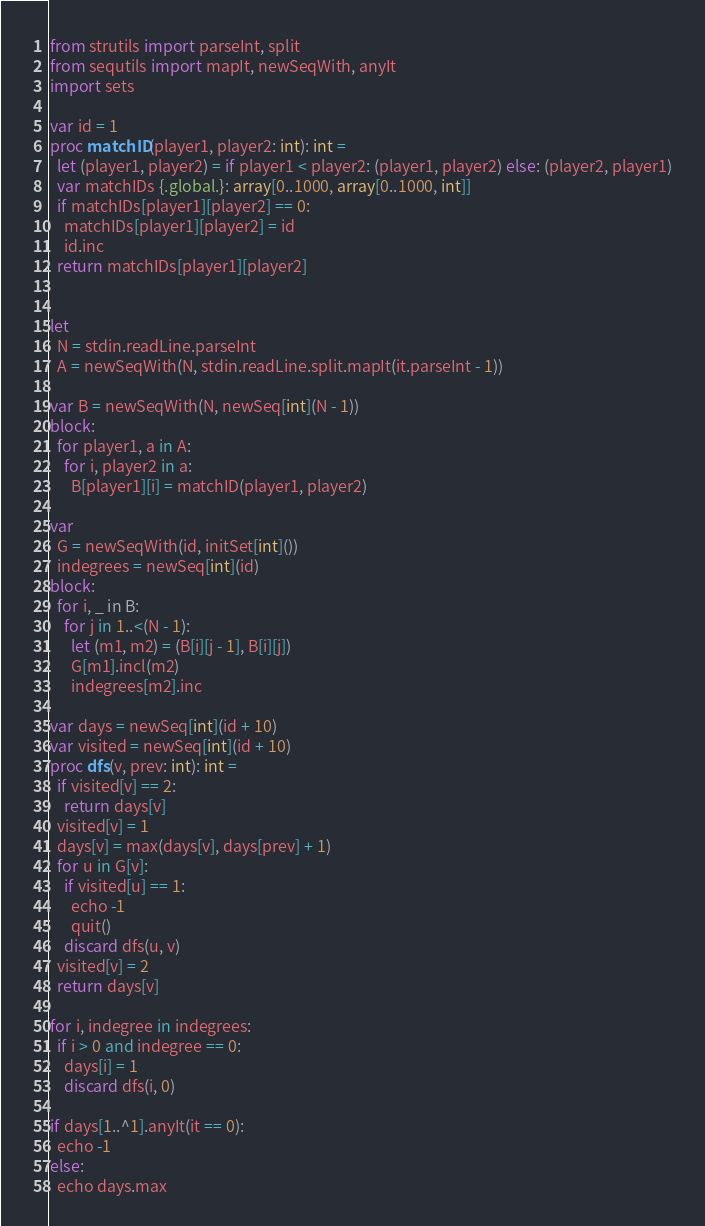<code> <loc_0><loc_0><loc_500><loc_500><_Nim_>from strutils import parseInt, split
from sequtils import mapIt, newSeqWith, anyIt
import sets

var id = 1
proc matchID(player1, player2: int): int =
  let (player1, player2) = if player1 < player2: (player1, player2) else: (player2, player1)
  var matchIDs {.global.}: array[0..1000, array[0..1000, int]]
  if matchIDs[player1][player2] == 0:
    matchIDs[player1][player2] = id
    id.inc
  return matchIDs[player1][player2]


let
  N = stdin.readLine.parseInt
  A = newSeqWith(N, stdin.readLine.split.mapIt(it.parseInt - 1))

var B = newSeqWith(N, newSeq[int](N - 1))
block:
  for player1, a in A:
    for i, player2 in a:
      B[player1][i] = matchID(player1, player2)

var
  G = newSeqWith(id, initSet[int]())
  indegrees = newSeq[int](id)
block:
  for i, _ in B:
    for j in 1..<(N - 1):
      let (m1, m2) = (B[i][j - 1], B[i][j])
      G[m1].incl(m2)
      indegrees[m2].inc

var days = newSeq[int](id + 10)
var visited = newSeq[int](id + 10)
proc dfs(v, prev: int): int =
  if visited[v] == 2:
    return days[v]
  visited[v] = 1
  days[v] = max(days[v], days[prev] + 1)
  for u in G[v]:
    if visited[u] == 1:
      echo -1
      quit()
    discard dfs(u, v)
  visited[v] = 2
  return days[v]

for i, indegree in indegrees:
  if i > 0 and indegree == 0:
    days[i] = 1
    discard dfs(i, 0)

if days[1..^1].anyIt(it == 0):
  echo -1
else:
  echo days.max
</code> 